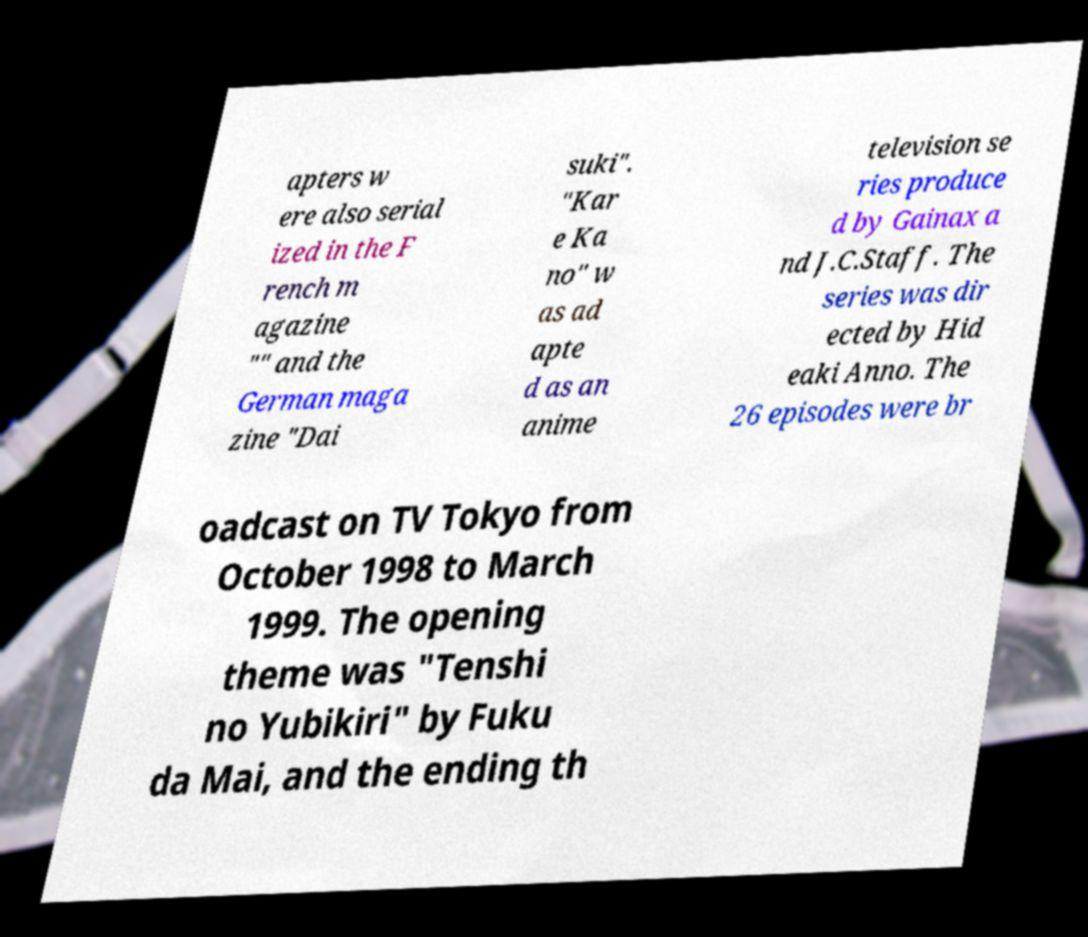Can you read and provide the text displayed in the image?This photo seems to have some interesting text. Can you extract and type it out for me? apters w ere also serial ized in the F rench m agazine "" and the German maga zine "Dai suki". "Kar e Ka no" w as ad apte d as an anime television se ries produce d by Gainax a nd J.C.Staff. The series was dir ected by Hid eaki Anno. The 26 episodes were br oadcast on TV Tokyo from October 1998 to March 1999. The opening theme was "Tenshi no Yubikiri" by Fuku da Mai, and the ending th 